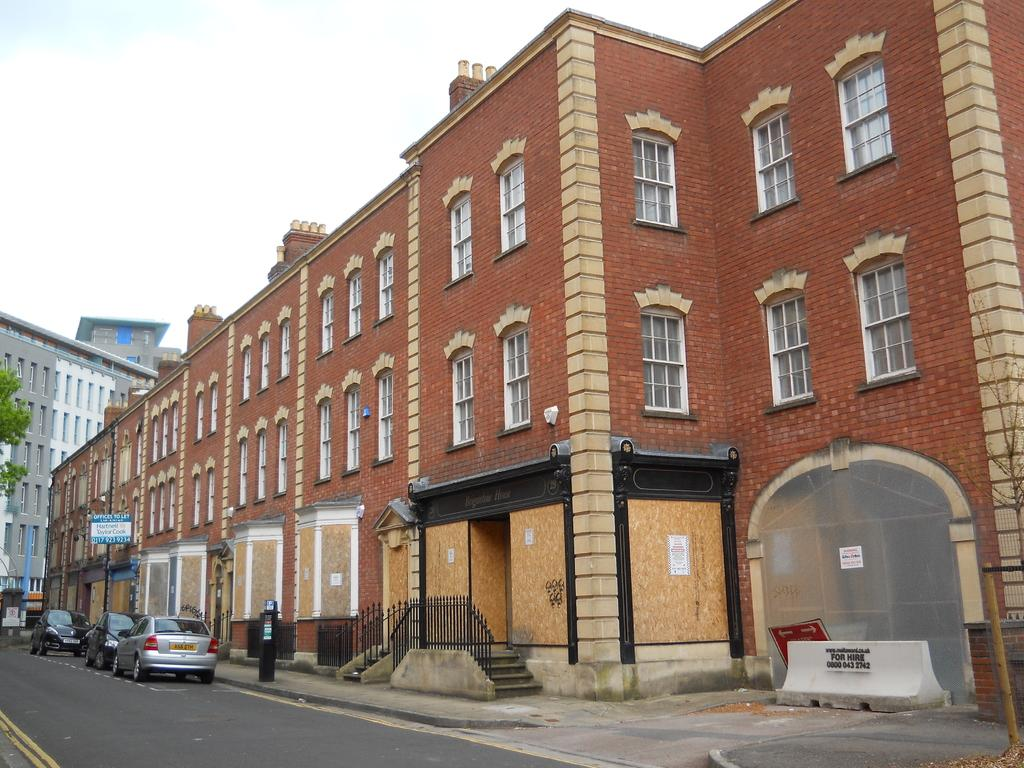What is the color of the building in the image? The building in the image is brown. What is located in front of the building? There is a road in front of the building. How many cars are parked on the side of the road? Three cars are parked on the side of the road. What can be seen in the background of the image? The sky is visible in the background of the image. Is there an umbrella being used by someone in the image? There is no umbrella present in the image. Is there a camp set up near the building in the image? There is no camp present in the image. 